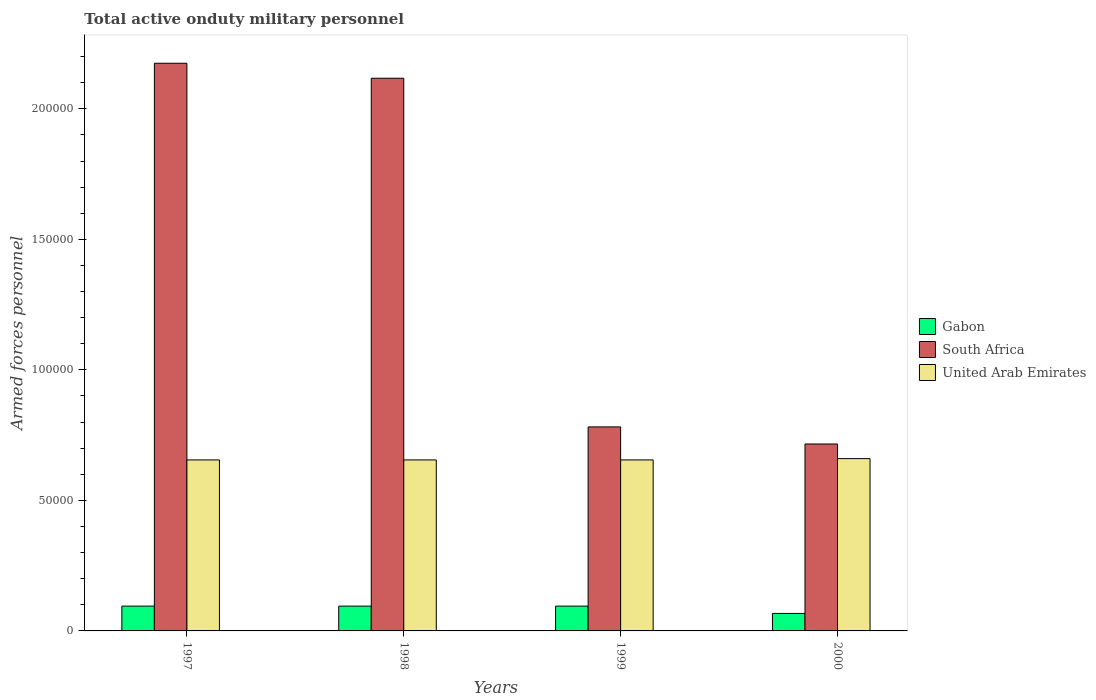How many different coloured bars are there?
Offer a very short reply. 3. How many groups of bars are there?
Give a very brief answer. 4. Are the number of bars on each tick of the X-axis equal?
Provide a short and direct response. Yes. How many bars are there on the 2nd tick from the left?
Ensure brevity in your answer.  3. How many bars are there on the 3rd tick from the right?
Keep it short and to the point. 3. What is the label of the 4th group of bars from the left?
Your answer should be very brief. 2000. What is the number of armed forces personnel in United Arab Emirates in 1997?
Offer a very short reply. 6.55e+04. Across all years, what is the maximum number of armed forces personnel in South Africa?
Your answer should be compact. 2.17e+05. Across all years, what is the minimum number of armed forces personnel in South Africa?
Give a very brief answer. 7.16e+04. What is the total number of armed forces personnel in South Africa in the graph?
Provide a succinct answer. 5.79e+05. What is the difference between the number of armed forces personnel in Gabon in 1997 and that in 1999?
Your response must be concise. 0. What is the difference between the number of armed forces personnel in Gabon in 2000 and the number of armed forces personnel in South Africa in 1997?
Your answer should be very brief. -2.11e+05. What is the average number of armed forces personnel in Gabon per year?
Make the answer very short. 8800. In the year 2000, what is the difference between the number of armed forces personnel in United Arab Emirates and number of armed forces personnel in South Africa?
Your answer should be very brief. -5600. In how many years, is the number of armed forces personnel in United Arab Emirates greater than 180000?
Keep it short and to the point. 0. What is the ratio of the number of armed forces personnel in Gabon in 1999 to that in 2000?
Your response must be concise. 1.42. Is the number of armed forces personnel in South Africa in 1997 less than that in 1998?
Offer a terse response. No. What is the difference between the highest and the second highest number of armed forces personnel in South Africa?
Provide a short and direct response. 5740. What is the difference between the highest and the lowest number of armed forces personnel in Gabon?
Ensure brevity in your answer.  2800. What does the 3rd bar from the left in 1999 represents?
Provide a succinct answer. United Arab Emirates. What does the 1st bar from the right in 1999 represents?
Ensure brevity in your answer.  United Arab Emirates. How many bars are there?
Ensure brevity in your answer.  12. What is the difference between two consecutive major ticks on the Y-axis?
Offer a very short reply. 5.00e+04. Are the values on the major ticks of Y-axis written in scientific E-notation?
Keep it short and to the point. No. Does the graph contain any zero values?
Your answer should be compact. No. Where does the legend appear in the graph?
Give a very brief answer. Center right. How are the legend labels stacked?
Your answer should be compact. Vertical. What is the title of the graph?
Ensure brevity in your answer.  Total active onduty military personnel. What is the label or title of the Y-axis?
Keep it short and to the point. Armed forces personnel. What is the Armed forces personnel in Gabon in 1997?
Your answer should be very brief. 9500. What is the Armed forces personnel of South Africa in 1997?
Provide a short and direct response. 2.17e+05. What is the Armed forces personnel of United Arab Emirates in 1997?
Provide a succinct answer. 6.55e+04. What is the Armed forces personnel of Gabon in 1998?
Your response must be concise. 9500. What is the Armed forces personnel in South Africa in 1998?
Offer a very short reply. 2.12e+05. What is the Armed forces personnel of United Arab Emirates in 1998?
Make the answer very short. 6.55e+04. What is the Armed forces personnel of Gabon in 1999?
Offer a very short reply. 9500. What is the Armed forces personnel in South Africa in 1999?
Offer a terse response. 7.82e+04. What is the Armed forces personnel of United Arab Emirates in 1999?
Your answer should be very brief. 6.55e+04. What is the Armed forces personnel in Gabon in 2000?
Your response must be concise. 6700. What is the Armed forces personnel in South Africa in 2000?
Give a very brief answer. 7.16e+04. What is the Armed forces personnel in United Arab Emirates in 2000?
Your answer should be very brief. 6.60e+04. Across all years, what is the maximum Armed forces personnel of Gabon?
Give a very brief answer. 9500. Across all years, what is the maximum Armed forces personnel in South Africa?
Offer a very short reply. 2.17e+05. Across all years, what is the maximum Armed forces personnel in United Arab Emirates?
Ensure brevity in your answer.  6.60e+04. Across all years, what is the minimum Armed forces personnel of Gabon?
Your response must be concise. 6700. Across all years, what is the minimum Armed forces personnel of South Africa?
Offer a terse response. 7.16e+04. Across all years, what is the minimum Armed forces personnel in United Arab Emirates?
Give a very brief answer. 6.55e+04. What is the total Armed forces personnel of Gabon in the graph?
Offer a terse response. 3.52e+04. What is the total Armed forces personnel of South Africa in the graph?
Give a very brief answer. 5.79e+05. What is the total Armed forces personnel in United Arab Emirates in the graph?
Your answer should be very brief. 2.62e+05. What is the difference between the Armed forces personnel of Gabon in 1997 and that in 1998?
Provide a short and direct response. 0. What is the difference between the Armed forces personnel in South Africa in 1997 and that in 1998?
Your answer should be very brief. 5740. What is the difference between the Armed forces personnel of South Africa in 1997 and that in 1999?
Ensure brevity in your answer.  1.39e+05. What is the difference between the Armed forces personnel in United Arab Emirates in 1997 and that in 1999?
Your response must be concise. 0. What is the difference between the Armed forces personnel of Gabon in 1997 and that in 2000?
Offer a very short reply. 2800. What is the difference between the Armed forces personnel in South Africa in 1997 and that in 2000?
Keep it short and to the point. 1.46e+05. What is the difference between the Armed forces personnel of United Arab Emirates in 1997 and that in 2000?
Give a very brief answer. -500. What is the difference between the Armed forces personnel of South Africa in 1998 and that in 1999?
Offer a very short reply. 1.34e+05. What is the difference between the Armed forces personnel in Gabon in 1998 and that in 2000?
Offer a very short reply. 2800. What is the difference between the Armed forces personnel of South Africa in 1998 and that in 2000?
Offer a terse response. 1.40e+05. What is the difference between the Armed forces personnel in United Arab Emirates in 1998 and that in 2000?
Keep it short and to the point. -500. What is the difference between the Armed forces personnel in Gabon in 1999 and that in 2000?
Your answer should be compact. 2800. What is the difference between the Armed forces personnel of South Africa in 1999 and that in 2000?
Offer a terse response. 6550. What is the difference between the Armed forces personnel of United Arab Emirates in 1999 and that in 2000?
Provide a succinct answer. -500. What is the difference between the Armed forces personnel in Gabon in 1997 and the Armed forces personnel in South Africa in 1998?
Provide a short and direct response. -2.02e+05. What is the difference between the Armed forces personnel of Gabon in 1997 and the Armed forces personnel of United Arab Emirates in 1998?
Provide a succinct answer. -5.60e+04. What is the difference between the Armed forces personnel in South Africa in 1997 and the Armed forces personnel in United Arab Emirates in 1998?
Your answer should be compact. 1.52e+05. What is the difference between the Armed forces personnel of Gabon in 1997 and the Armed forces personnel of South Africa in 1999?
Ensure brevity in your answer.  -6.86e+04. What is the difference between the Armed forces personnel in Gabon in 1997 and the Armed forces personnel in United Arab Emirates in 1999?
Your answer should be compact. -5.60e+04. What is the difference between the Armed forces personnel in South Africa in 1997 and the Armed forces personnel in United Arab Emirates in 1999?
Your response must be concise. 1.52e+05. What is the difference between the Armed forces personnel of Gabon in 1997 and the Armed forces personnel of South Africa in 2000?
Make the answer very short. -6.21e+04. What is the difference between the Armed forces personnel in Gabon in 1997 and the Armed forces personnel in United Arab Emirates in 2000?
Your answer should be very brief. -5.65e+04. What is the difference between the Armed forces personnel of South Africa in 1997 and the Armed forces personnel of United Arab Emirates in 2000?
Your answer should be compact. 1.51e+05. What is the difference between the Armed forces personnel of Gabon in 1998 and the Armed forces personnel of South Africa in 1999?
Your response must be concise. -6.86e+04. What is the difference between the Armed forces personnel in Gabon in 1998 and the Armed forces personnel in United Arab Emirates in 1999?
Offer a terse response. -5.60e+04. What is the difference between the Armed forces personnel in South Africa in 1998 and the Armed forces personnel in United Arab Emirates in 1999?
Keep it short and to the point. 1.46e+05. What is the difference between the Armed forces personnel of Gabon in 1998 and the Armed forces personnel of South Africa in 2000?
Offer a terse response. -6.21e+04. What is the difference between the Armed forces personnel in Gabon in 1998 and the Armed forces personnel in United Arab Emirates in 2000?
Keep it short and to the point. -5.65e+04. What is the difference between the Armed forces personnel of South Africa in 1998 and the Armed forces personnel of United Arab Emirates in 2000?
Offer a terse response. 1.46e+05. What is the difference between the Armed forces personnel in Gabon in 1999 and the Armed forces personnel in South Africa in 2000?
Provide a short and direct response. -6.21e+04. What is the difference between the Armed forces personnel in Gabon in 1999 and the Armed forces personnel in United Arab Emirates in 2000?
Provide a succinct answer. -5.65e+04. What is the difference between the Armed forces personnel in South Africa in 1999 and the Armed forces personnel in United Arab Emirates in 2000?
Your answer should be very brief. 1.22e+04. What is the average Armed forces personnel of Gabon per year?
Give a very brief answer. 8800. What is the average Armed forces personnel of South Africa per year?
Your answer should be compact. 1.45e+05. What is the average Armed forces personnel in United Arab Emirates per year?
Your answer should be very brief. 6.56e+04. In the year 1997, what is the difference between the Armed forces personnel of Gabon and Armed forces personnel of South Africa?
Your answer should be very brief. -2.08e+05. In the year 1997, what is the difference between the Armed forces personnel in Gabon and Armed forces personnel in United Arab Emirates?
Ensure brevity in your answer.  -5.60e+04. In the year 1997, what is the difference between the Armed forces personnel of South Africa and Armed forces personnel of United Arab Emirates?
Make the answer very short. 1.52e+05. In the year 1998, what is the difference between the Armed forces personnel of Gabon and Armed forces personnel of South Africa?
Keep it short and to the point. -2.02e+05. In the year 1998, what is the difference between the Armed forces personnel in Gabon and Armed forces personnel in United Arab Emirates?
Offer a very short reply. -5.60e+04. In the year 1998, what is the difference between the Armed forces personnel in South Africa and Armed forces personnel in United Arab Emirates?
Your response must be concise. 1.46e+05. In the year 1999, what is the difference between the Armed forces personnel in Gabon and Armed forces personnel in South Africa?
Provide a succinct answer. -6.86e+04. In the year 1999, what is the difference between the Armed forces personnel of Gabon and Armed forces personnel of United Arab Emirates?
Give a very brief answer. -5.60e+04. In the year 1999, what is the difference between the Armed forces personnel of South Africa and Armed forces personnel of United Arab Emirates?
Provide a succinct answer. 1.26e+04. In the year 2000, what is the difference between the Armed forces personnel of Gabon and Armed forces personnel of South Africa?
Offer a terse response. -6.49e+04. In the year 2000, what is the difference between the Armed forces personnel of Gabon and Armed forces personnel of United Arab Emirates?
Your response must be concise. -5.93e+04. In the year 2000, what is the difference between the Armed forces personnel of South Africa and Armed forces personnel of United Arab Emirates?
Your response must be concise. 5600. What is the ratio of the Armed forces personnel in South Africa in 1997 to that in 1998?
Ensure brevity in your answer.  1.03. What is the ratio of the Armed forces personnel of United Arab Emirates in 1997 to that in 1998?
Provide a short and direct response. 1. What is the ratio of the Armed forces personnel of Gabon in 1997 to that in 1999?
Your answer should be very brief. 1. What is the ratio of the Armed forces personnel in South Africa in 1997 to that in 1999?
Provide a short and direct response. 2.78. What is the ratio of the Armed forces personnel of United Arab Emirates in 1997 to that in 1999?
Make the answer very short. 1. What is the ratio of the Armed forces personnel of Gabon in 1997 to that in 2000?
Your answer should be very brief. 1.42. What is the ratio of the Armed forces personnel in South Africa in 1997 to that in 2000?
Provide a short and direct response. 3.04. What is the ratio of the Armed forces personnel in United Arab Emirates in 1997 to that in 2000?
Offer a terse response. 0.99. What is the ratio of the Armed forces personnel of Gabon in 1998 to that in 1999?
Offer a terse response. 1. What is the ratio of the Armed forces personnel of South Africa in 1998 to that in 1999?
Keep it short and to the point. 2.71. What is the ratio of the Armed forces personnel in United Arab Emirates in 1998 to that in 1999?
Make the answer very short. 1. What is the ratio of the Armed forces personnel in Gabon in 1998 to that in 2000?
Make the answer very short. 1.42. What is the ratio of the Armed forces personnel in South Africa in 1998 to that in 2000?
Your answer should be compact. 2.96. What is the ratio of the Armed forces personnel of United Arab Emirates in 1998 to that in 2000?
Offer a terse response. 0.99. What is the ratio of the Armed forces personnel of Gabon in 1999 to that in 2000?
Provide a succinct answer. 1.42. What is the ratio of the Armed forces personnel in South Africa in 1999 to that in 2000?
Your answer should be compact. 1.09. What is the difference between the highest and the second highest Armed forces personnel in South Africa?
Provide a short and direct response. 5740. What is the difference between the highest and the lowest Armed forces personnel of Gabon?
Give a very brief answer. 2800. What is the difference between the highest and the lowest Armed forces personnel of South Africa?
Your answer should be very brief. 1.46e+05. What is the difference between the highest and the lowest Armed forces personnel of United Arab Emirates?
Make the answer very short. 500. 